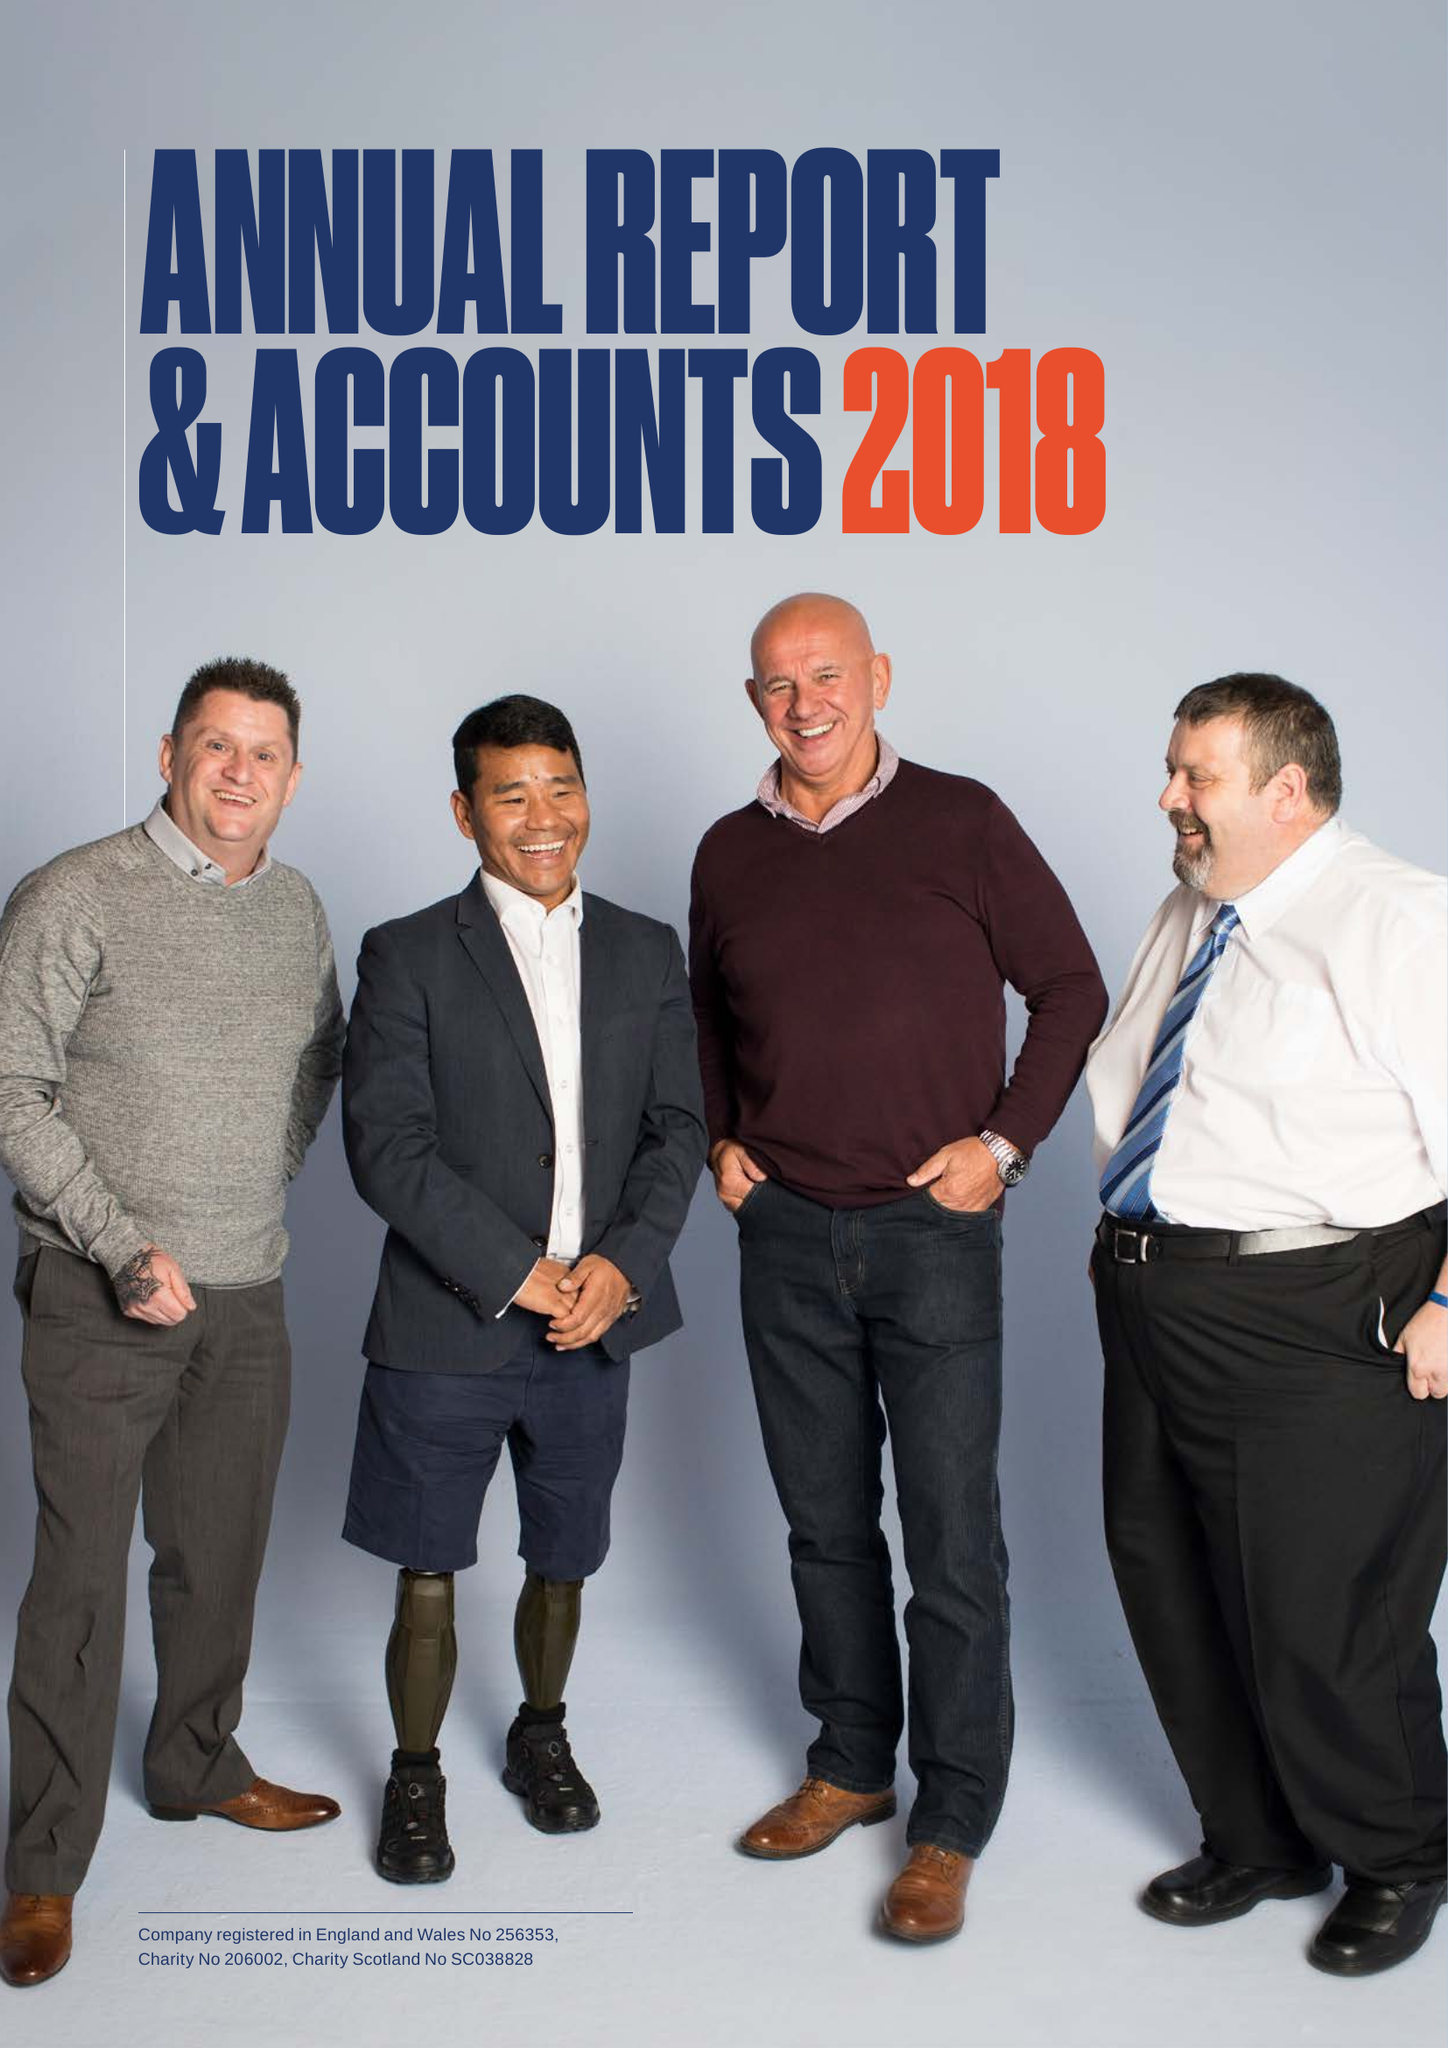What is the value for the address__post_town?
Answer the question using a single word or phrase. LEATHERHEAD 